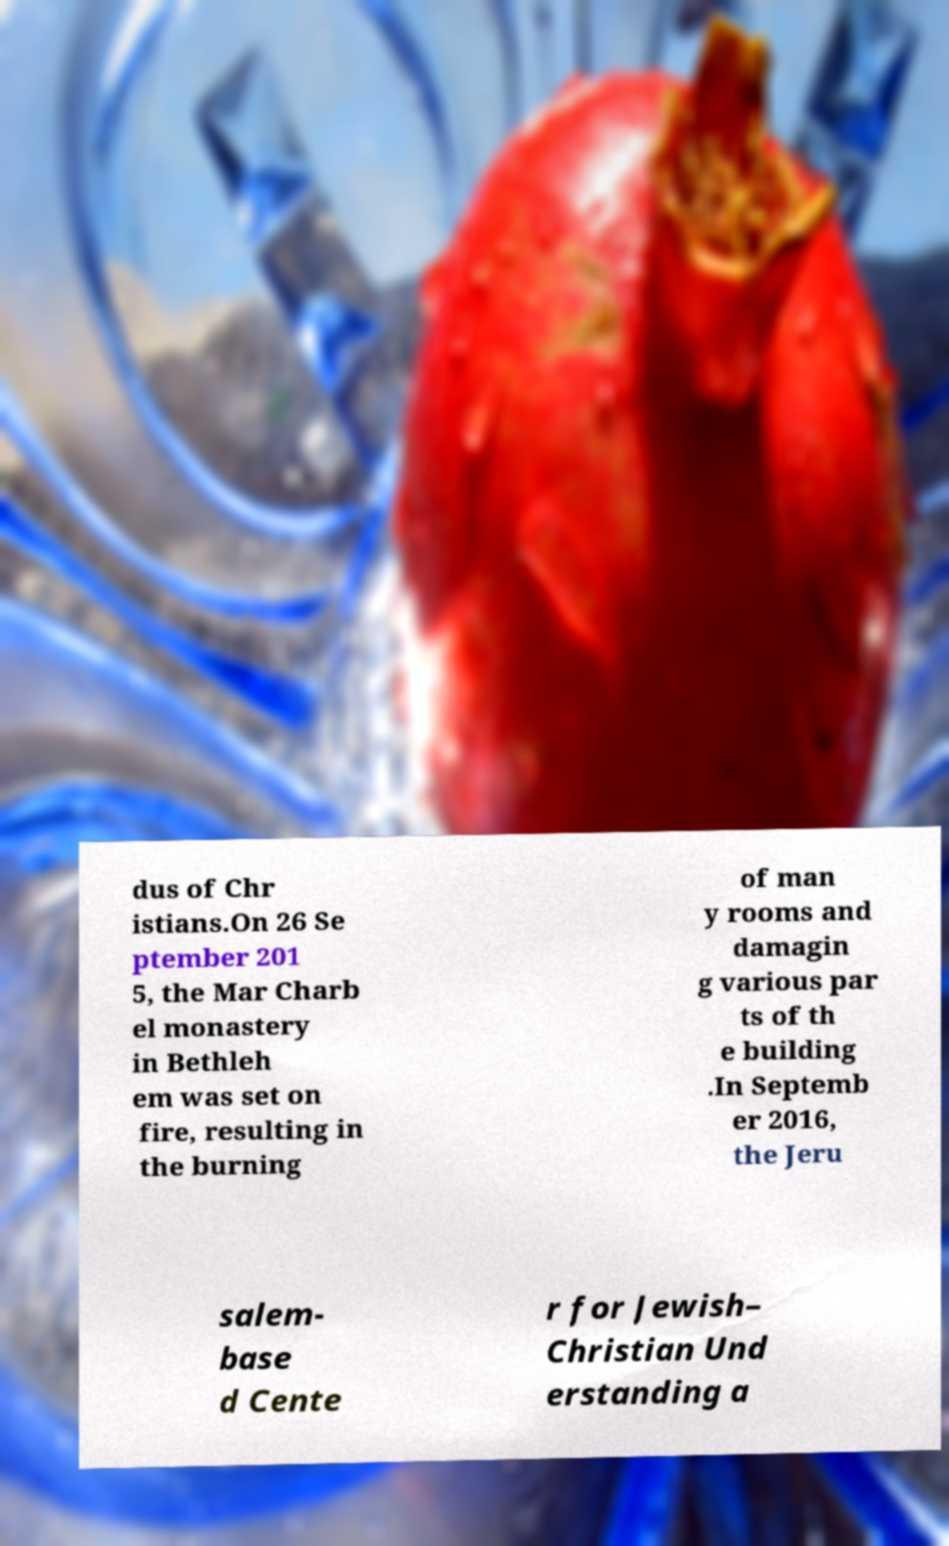Can you accurately transcribe the text from the provided image for me? dus of Chr istians.On 26 Se ptember 201 5, the Mar Charb el monastery in Bethleh em was set on fire, resulting in the burning of man y rooms and damagin g various par ts of th e building .In Septemb er 2016, the Jeru salem- base d Cente r for Jewish– Christian Und erstanding a 